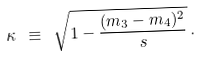Convert formula to latex. <formula><loc_0><loc_0><loc_500><loc_500>\kappa \ \equiv \ \sqrt { 1 - \frac { ( m _ { 3 } - m _ { 4 } ) ^ { 2 } } { s } } \, .</formula> 